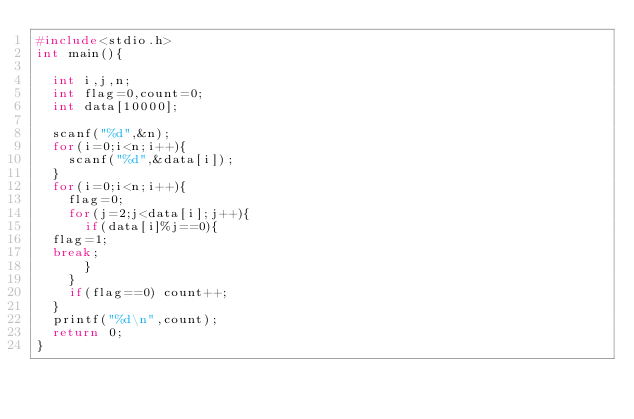<code> <loc_0><loc_0><loc_500><loc_500><_C_>#include<stdio.h>
int main(){

  int i,j,n;
  int flag=0,count=0;
  int data[10000];

  scanf("%d",&n);
  for(i=0;i<n;i++){
    scanf("%d",&data[i]);
  }
  for(i=0;i<n;i++){
    flag=0;
    for(j=2;j<data[i];j++){
      if(data[i]%j==0){
	flag=1;
	break;
      }
    }
    if(flag==0) count++;
  }
  printf("%d\n",count);
  return 0;
}

</code> 